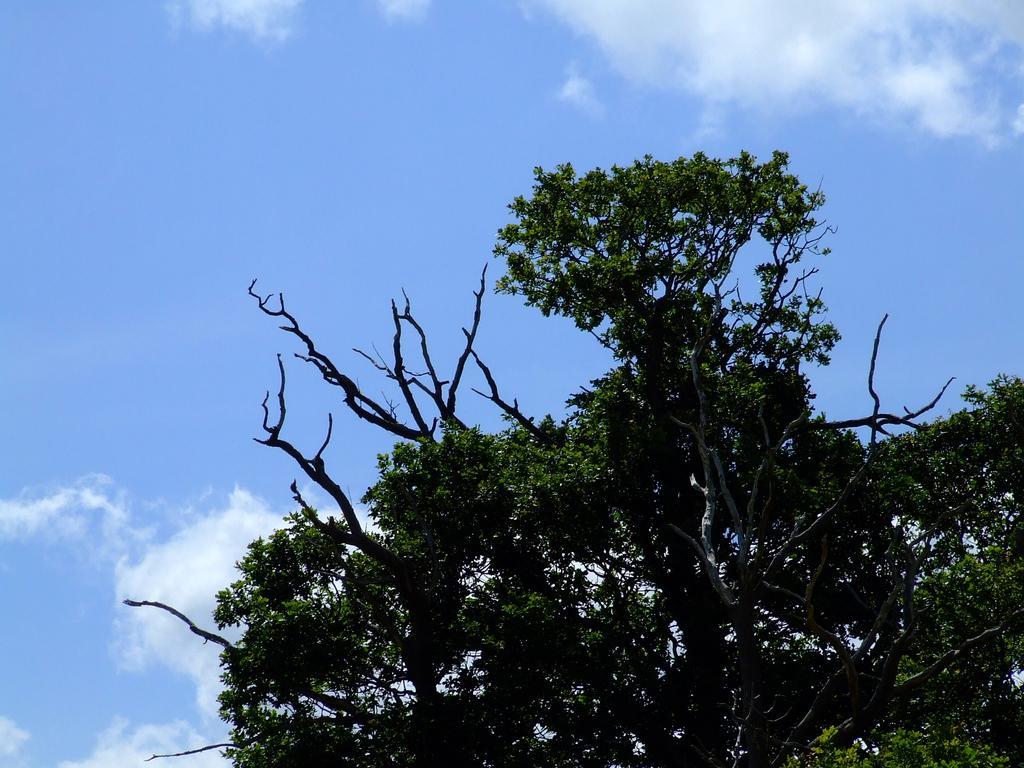How would you summarize this image in a sentence or two? In this image there are trees with branches and leaves, at the top of the image there are clouds in the sky. 